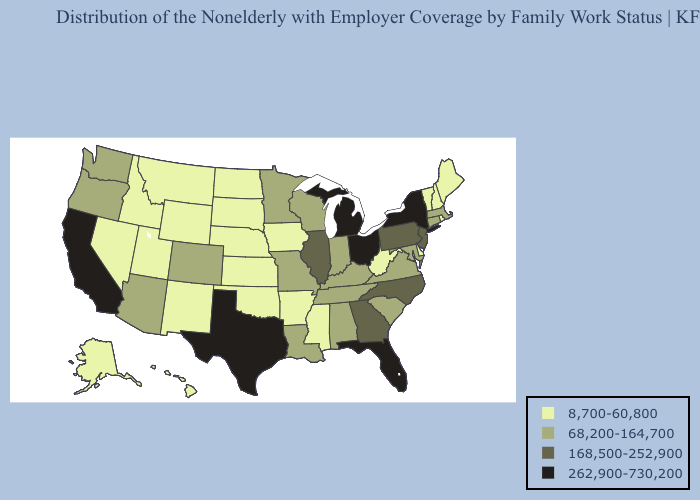Which states hav the highest value in the Northeast?
Be succinct. New York. What is the highest value in states that border Georgia?
Write a very short answer. 262,900-730,200. Which states have the highest value in the USA?
Keep it brief. California, Florida, Michigan, New York, Ohio, Texas. What is the lowest value in the South?
Answer briefly. 8,700-60,800. What is the highest value in the USA?
Answer briefly. 262,900-730,200. What is the value of South Carolina?
Short answer required. 68,200-164,700. Name the states that have a value in the range 262,900-730,200?
Be succinct. California, Florida, Michigan, New York, Ohio, Texas. How many symbols are there in the legend?
Answer briefly. 4. Name the states that have a value in the range 68,200-164,700?
Be succinct. Alabama, Arizona, Colorado, Connecticut, Indiana, Kentucky, Louisiana, Maryland, Massachusetts, Minnesota, Missouri, Oregon, South Carolina, Tennessee, Virginia, Washington, Wisconsin. Does Montana have the highest value in the USA?
Keep it brief. No. Does the map have missing data?
Write a very short answer. No. Name the states that have a value in the range 8,700-60,800?
Be succinct. Alaska, Arkansas, Delaware, Hawaii, Idaho, Iowa, Kansas, Maine, Mississippi, Montana, Nebraska, Nevada, New Hampshire, New Mexico, North Dakota, Oklahoma, Rhode Island, South Dakota, Utah, Vermont, West Virginia, Wyoming. What is the value of Maine?
Be succinct. 8,700-60,800. What is the value of Kansas?
Write a very short answer. 8,700-60,800. Among the states that border North Carolina , does Georgia have the highest value?
Write a very short answer. Yes. 